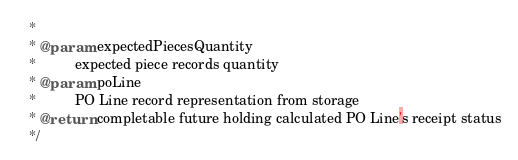<code> <loc_0><loc_0><loc_500><loc_500><_Java_>   *
   * @param expectedPiecesQuantity
   *          expected piece records quantity
   * @param poLine
   *          PO Line record representation from storage
   * @return completable future holding calculated PO Line's receipt status
   */</code> 